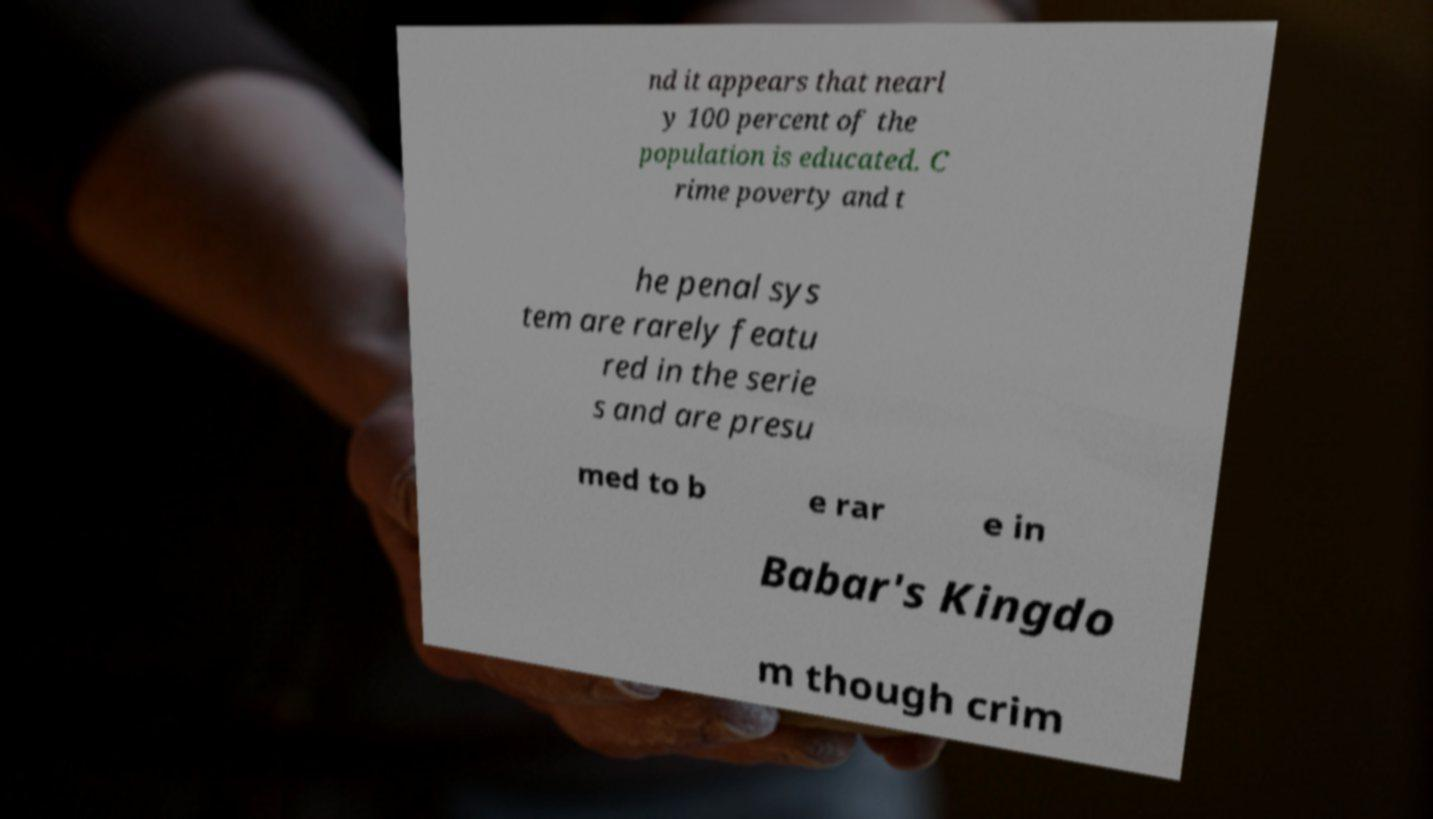Could you extract and type out the text from this image? nd it appears that nearl y 100 percent of the population is educated. C rime poverty and t he penal sys tem are rarely featu red in the serie s and are presu med to b e rar e in Babar's Kingdo m though crim 